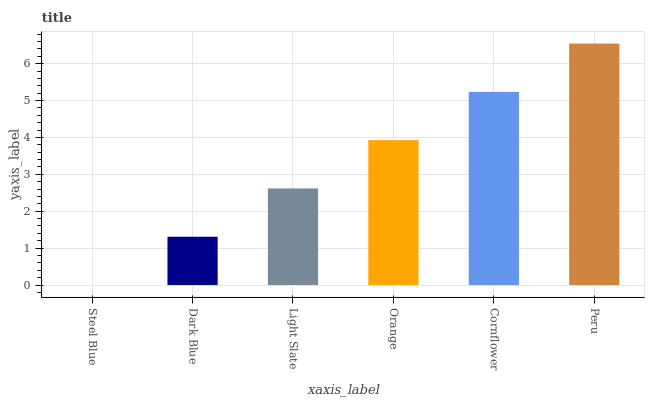Is Dark Blue the minimum?
Answer yes or no. No. Is Dark Blue the maximum?
Answer yes or no. No. Is Dark Blue greater than Steel Blue?
Answer yes or no. Yes. Is Steel Blue less than Dark Blue?
Answer yes or no. Yes. Is Steel Blue greater than Dark Blue?
Answer yes or no. No. Is Dark Blue less than Steel Blue?
Answer yes or no. No. Is Orange the high median?
Answer yes or no. Yes. Is Light Slate the low median?
Answer yes or no. Yes. Is Dark Blue the high median?
Answer yes or no. No. Is Orange the low median?
Answer yes or no. No. 